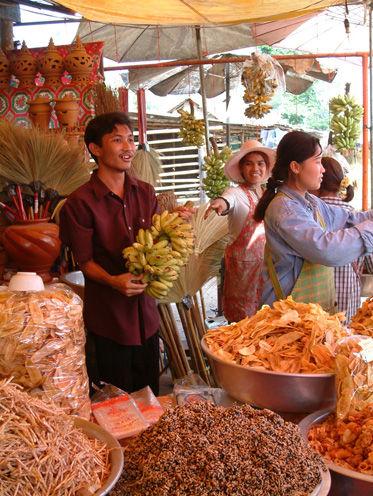What kind of food is on the far bottom left?
Quick response, please. Noodles. Is it day or night?
Write a very short answer. Day. What is the man wearing?
Concise answer only. Shirt. 